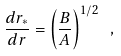<formula> <loc_0><loc_0><loc_500><loc_500>\frac { d r _ { * } } { d r } = \left ( \frac { B } { A } \right ) ^ { 1 / 2 } \ ,</formula> 